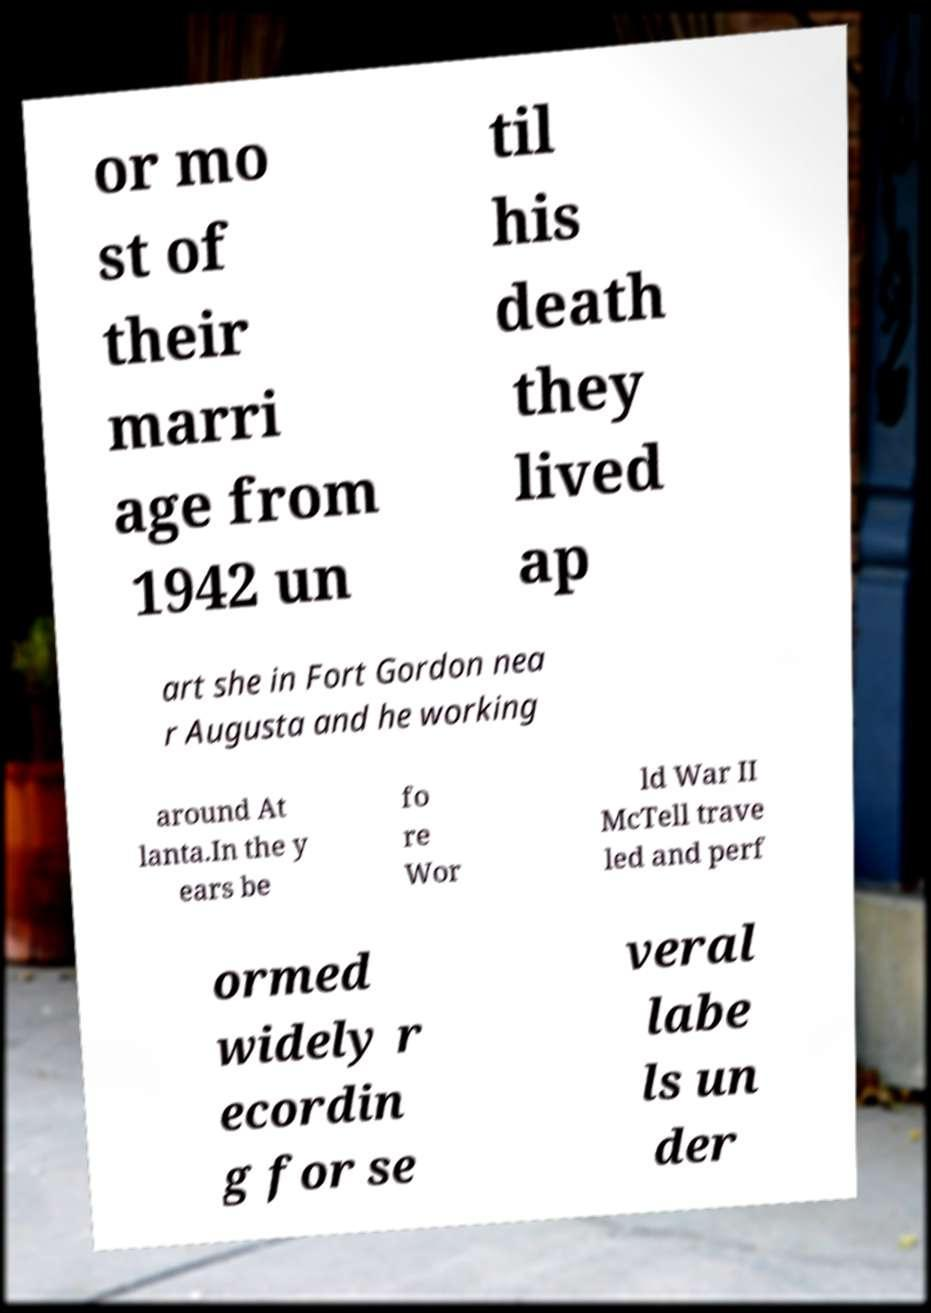Can you read and provide the text displayed in the image?This photo seems to have some interesting text. Can you extract and type it out for me? or mo st of their marri age from 1942 un til his death they lived ap art she in Fort Gordon nea r Augusta and he working around At lanta.In the y ears be fo re Wor ld War II McTell trave led and perf ormed widely r ecordin g for se veral labe ls un der 